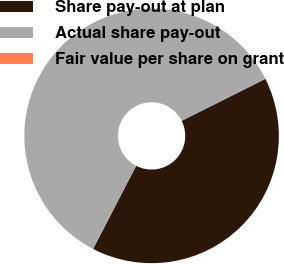Convert chart. <chart><loc_0><loc_0><loc_500><loc_500><pie_chart><fcel>Share pay-out at plan<fcel>Actual share pay-out<fcel>Fair value per share on grant<nl><fcel>40.0%<fcel>60.0%<fcel>0.0%<nl></chart> 